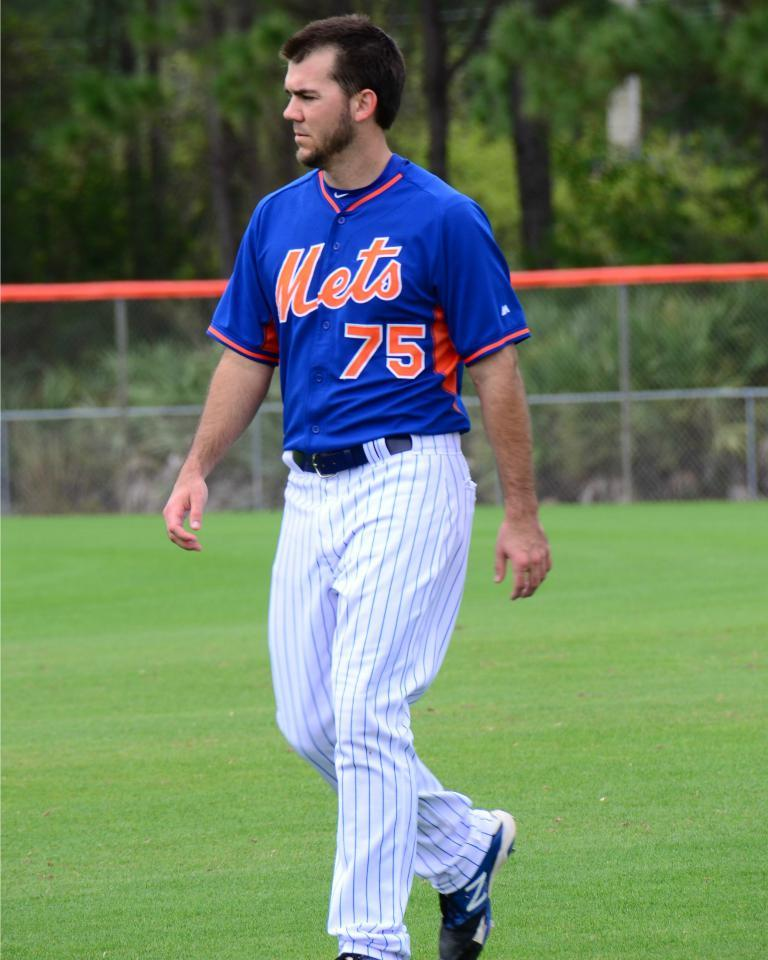<image>
Offer a succinct explanation of the picture presented. a player that has a Mets jersey on their back 